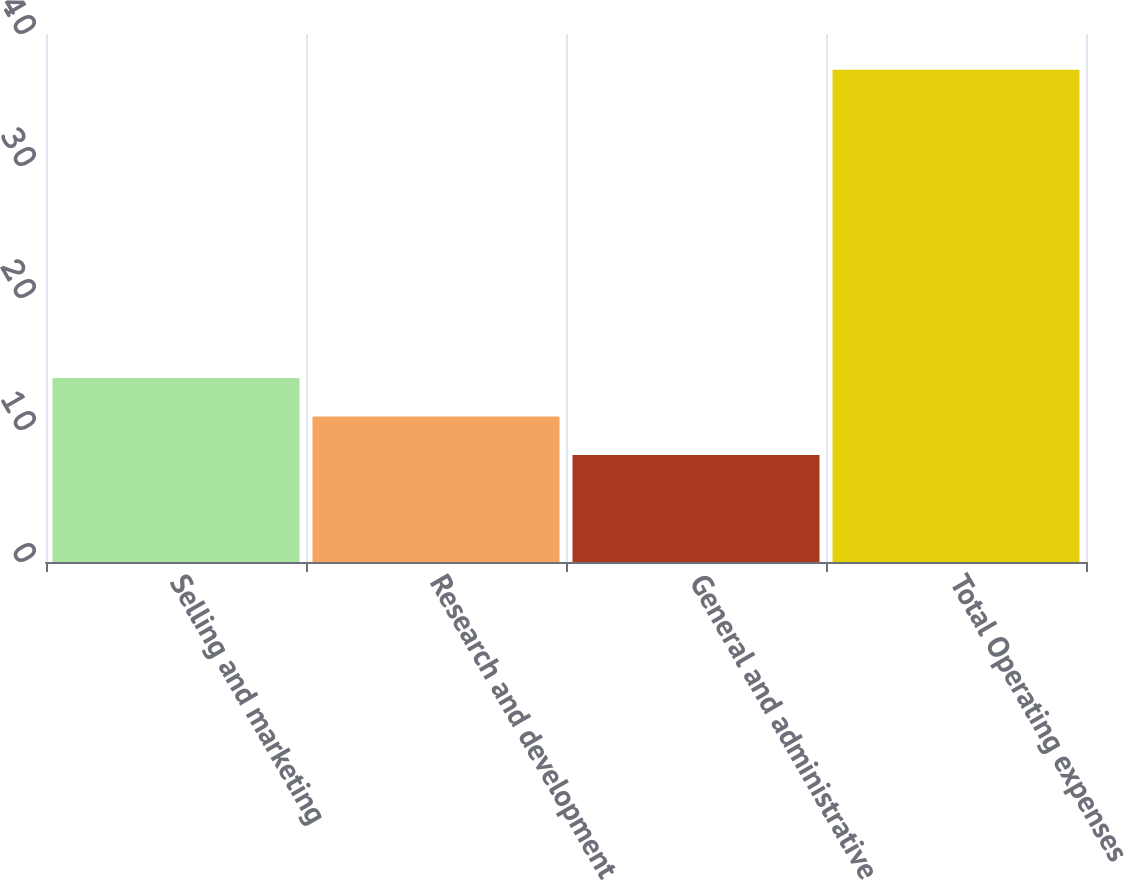Convert chart. <chart><loc_0><loc_0><loc_500><loc_500><bar_chart><fcel>Selling and marketing<fcel>Research and development<fcel>General and administrative<fcel>Total Operating expenses<nl><fcel>13.94<fcel>11.02<fcel>8.1<fcel>37.3<nl></chart> 